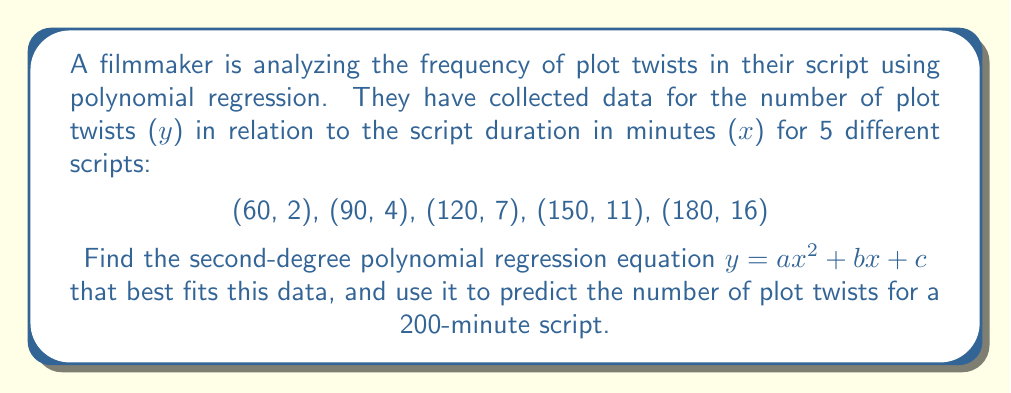Teach me how to tackle this problem. 1) To find the polynomial regression equation, we need to solve the normal equations:

   $$\begin{cases}
   \sum y = an\sum x^2 + b\sum x + nc \\
   \sum xy = a\sum x^3 + b\sum x^2 + c\sum x \\
   \sum x^2y = a\sum x^4 + b\sum x^3 + c\sum x^2
   \end{cases}$$

2) Calculate the sums:
   $\sum x = 600$, $\sum y = 40$, $\sum x^2 = 90000$, $\sum x^3 = 15300000$
   $\sum x^4 = 2745000000$, $\sum xy = 6300$, $\sum x^2y = 1035000$

3) Substitute these values into the normal equations:

   $$\begin{cases}
   40 = 90000a + 600b + 5c \\
   6300 = 15300000a + 90000b + 600c \\
   1035000 = 2745000000a + 15300000b + 90000c
   \end{cases}$$

4) Solve this system of equations (using a computer algebra system or matrix methods):

   $a \approx 0.00111111$, $b \approx -0.0666667$, $c \approx 0.555556$

5) The polynomial regression equation is:

   $y = 0.00111111x^2 - 0.0666667x + 0.555556$

6) To predict the number of plot twists for a 200-minute script, substitute x = 200:

   $y = 0.00111111(200)^2 - 0.0666667(200) + 0.555556$
   $y = 44.44444 - 13.33334 + 0.555556$
   $y \approx 31.67$
Answer: $y = 0.00111111x^2 - 0.0666667x + 0.555556$; 31.67 plot twists for a 200-minute script 